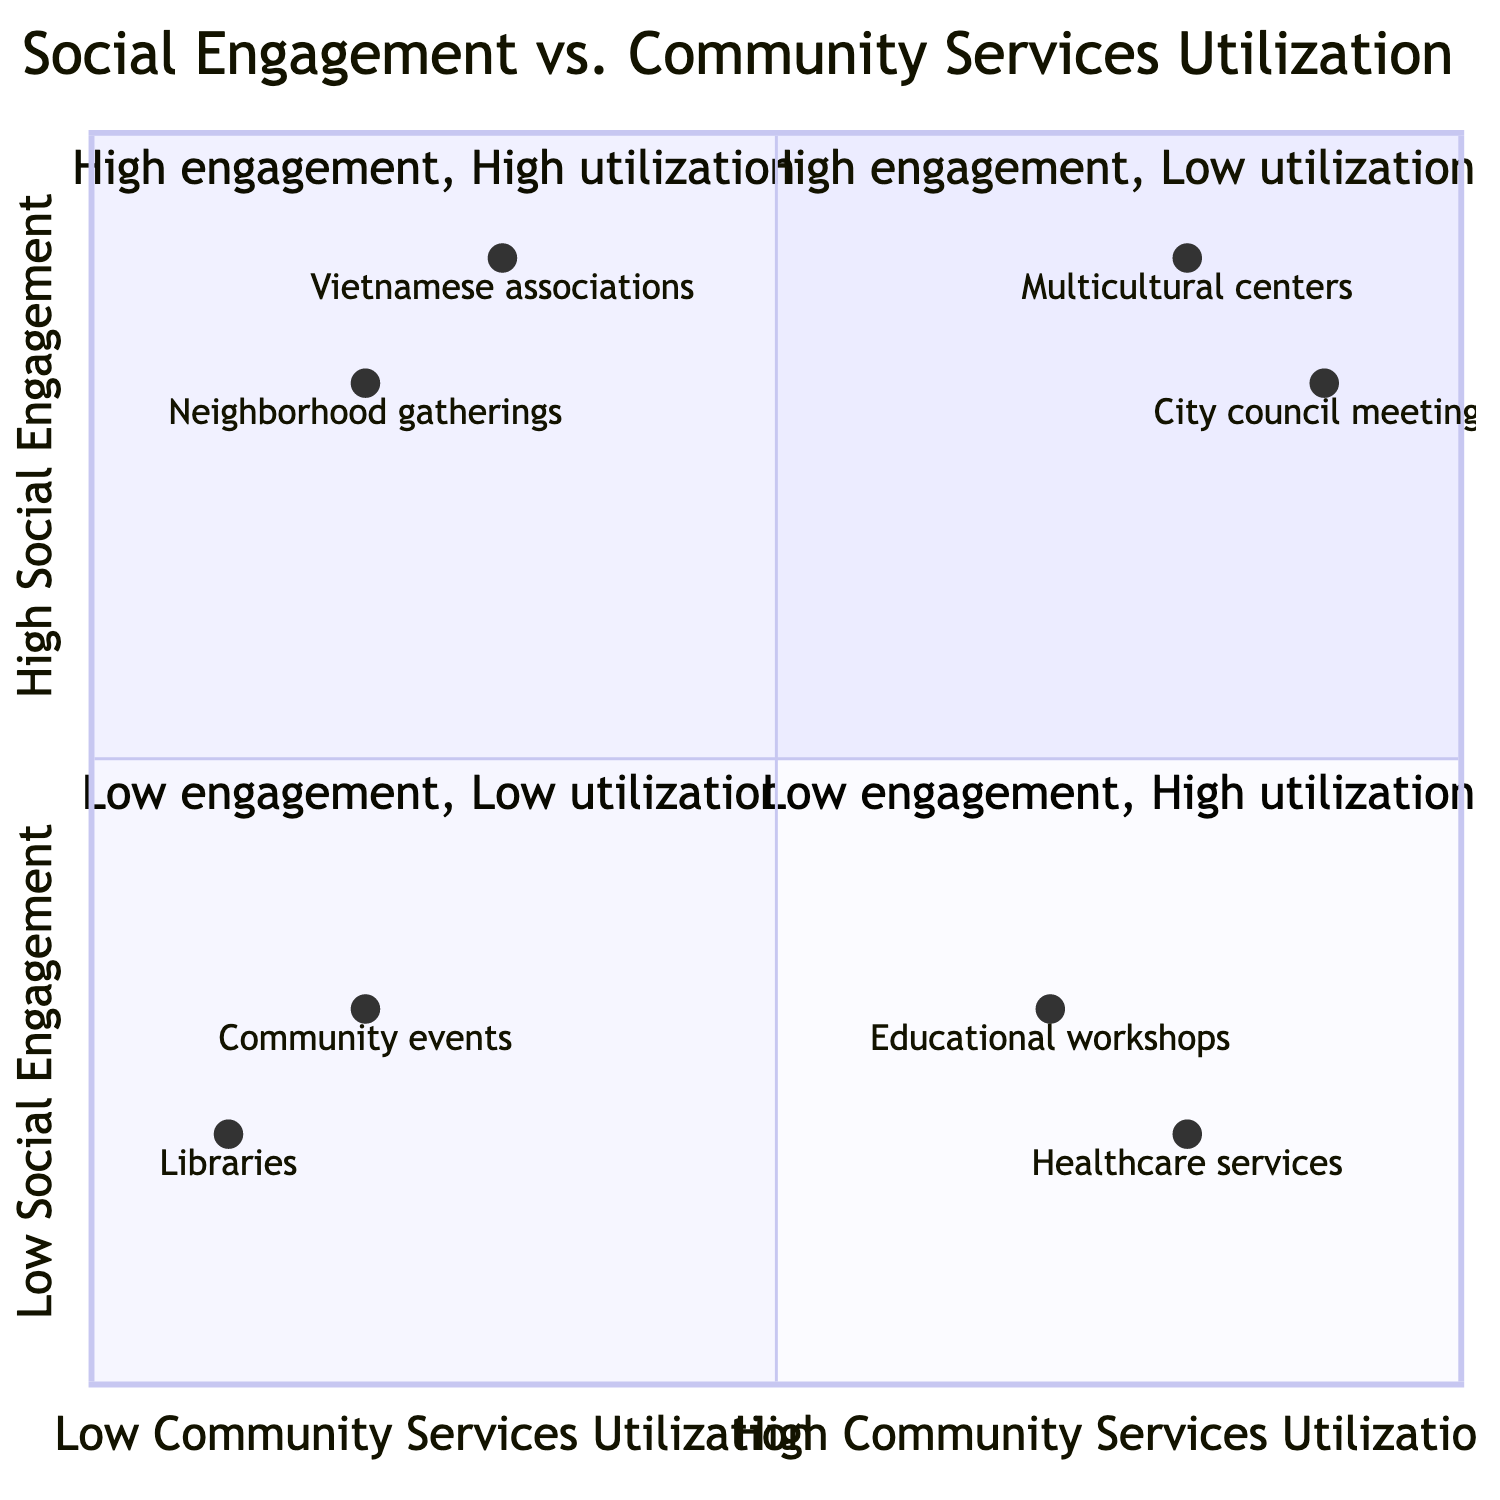What is the example of high engagement and low utilization? The quadrant labeled "high utilization low engagement" includes examples of people who actively engage socially but do not utilize community services. One example is "Active participation in informal social groups such as neighborhood gatherings," which fits this category.
Answer: Active participation in informal social groups such as neighborhood gatherings Which quadrant represents low engagement and low utilization? The quadrant labeled "low engagement low utilization" specifically describes individuals who neither participate in community services nor engage socially. This quadrant is characterized by examples such as rare visits to local libraries.
Answer: Low engagement and low utilization How many examples are listed in the high utilization and high engagement quadrant? In the quadrant of "high utilization high engagement," there are two examples provided: active involvement in city council meetings and consistent participation in multicultural community centers. Therefore, the count is two.
Answer: Two What is an example from the quadrant with high utilization but low engagement? The quadrant for "high utilization low engagement" includes instances where individuals may use services frequently but do not interact meaningfully in social contexts. An example given is "Regular usage of healthcare services like clinics, but limited interaction with service staff."
Answer: Regular usage of healthcare services like clinics, but limited interaction with service staff Which example indicates high social engagement? Examples in the quadrant labeled "low utilization high engagement" illustrate high social engagement without extensive use of community services. One of these is "Frequent social activities with local Vietnamese associations," indicating strong engagement.
Answer: Frequent social activities with local Vietnamese associations 